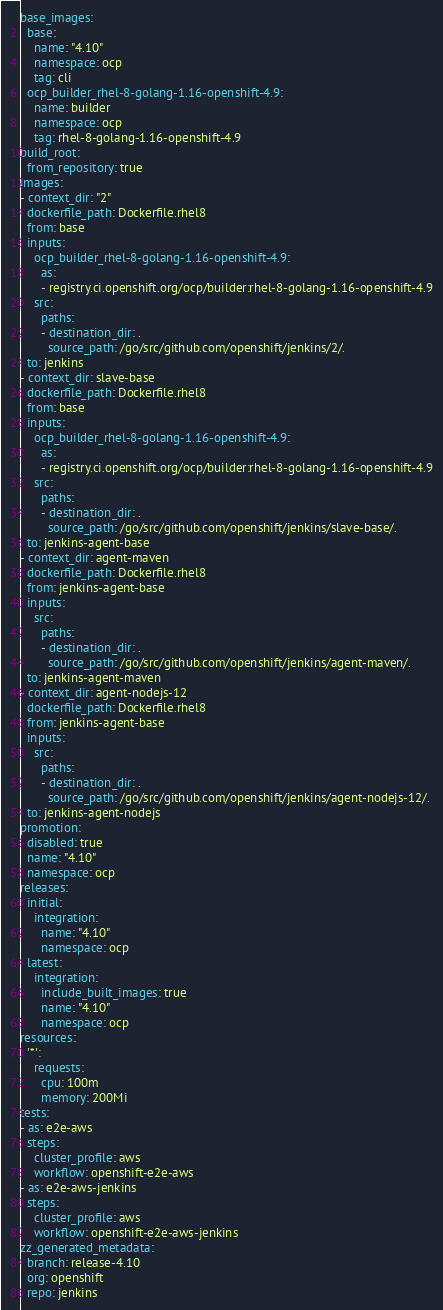Convert code to text. <code><loc_0><loc_0><loc_500><loc_500><_YAML_>base_images:
  base:
    name: "4.10"
    namespace: ocp
    tag: cli
  ocp_builder_rhel-8-golang-1.16-openshift-4.9:
    name: builder
    namespace: ocp
    tag: rhel-8-golang-1.16-openshift-4.9
build_root:
  from_repository: true
images:
- context_dir: "2"
  dockerfile_path: Dockerfile.rhel8
  from: base
  inputs:
    ocp_builder_rhel-8-golang-1.16-openshift-4.9:
      as:
      - registry.ci.openshift.org/ocp/builder:rhel-8-golang-1.16-openshift-4.9
    src:
      paths:
      - destination_dir: .
        source_path: /go/src/github.com/openshift/jenkins/2/.
  to: jenkins
- context_dir: slave-base
  dockerfile_path: Dockerfile.rhel8
  from: base
  inputs:
    ocp_builder_rhel-8-golang-1.16-openshift-4.9:
      as:
      - registry.ci.openshift.org/ocp/builder:rhel-8-golang-1.16-openshift-4.9
    src:
      paths:
      - destination_dir: .
        source_path: /go/src/github.com/openshift/jenkins/slave-base/.
  to: jenkins-agent-base
- context_dir: agent-maven
  dockerfile_path: Dockerfile.rhel8
  from: jenkins-agent-base
  inputs:
    src:
      paths:
      - destination_dir: .
        source_path: /go/src/github.com/openshift/jenkins/agent-maven/.
  to: jenkins-agent-maven
- context_dir: agent-nodejs-12
  dockerfile_path: Dockerfile.rhel8
  from: jenkins-agent-base
  inputs:
    src:
      paths:
      - destination_dir: .
        source_path: /go/src/github.com/openshift/jenkins/agent-nodejs-12/.
  to: jenkins-agent-nodejs
promotion:
  disabled: true
  name: "4.10"
  namespace: ocp
releases:
  initial:
    integration:
      name: "4.10"
      namespace: ocp
  latest:
    integration:
      include_built_images: true
      name: "4.10"
      namespace: ocp
resources:
  '*':
    requests:
      cpu: 100m
      memory: 200Mi
tests:
- as: e2e-aws
  steps:
    cluster_profile: aws
    workflow: openshift-e2e-aws
- as: e2e-aws-jenkins
  steps:
    cluster_profile: aws
    workflow: openshift-e2e-aws-jenkins
zz_generated_metadata:
  branch: release-4.10
  org: openshift
  repo: jenkins
</code> 